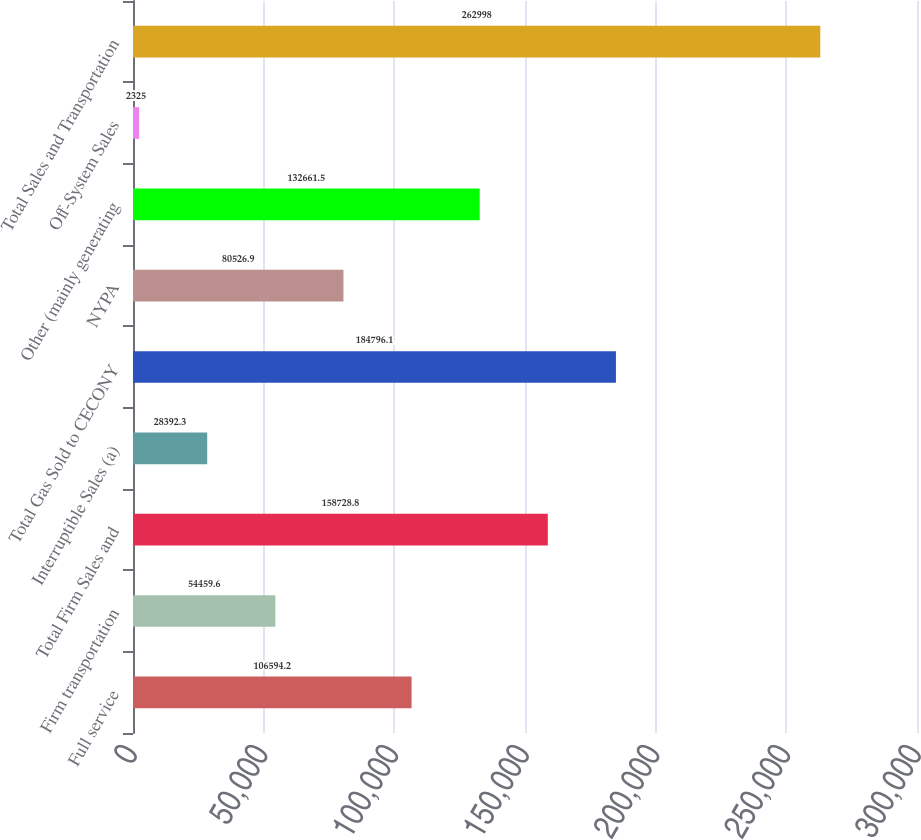Convert chart to OTSL. <chart><loc_0><loc_0><loc_500><loc_500><bar_chart><fcel>Full service<fcel>Firm transportation<fcel>Total Firm Sales and<fcel>Interruptible Sales (a)<fcel>Total Gas Sold to CECONY<fcel>NYPA<fcel>Other (mainly generating<fcel>Off-System Sales<fcel>Total Sales and Transportation<nl><fcel>106594<fcel>54459.6<fcel>158729<fcel>28392.3<fcel>184796<fcel>80526.9<fcel>132662<fcel>2325<fcel>262998<nl></chart> 